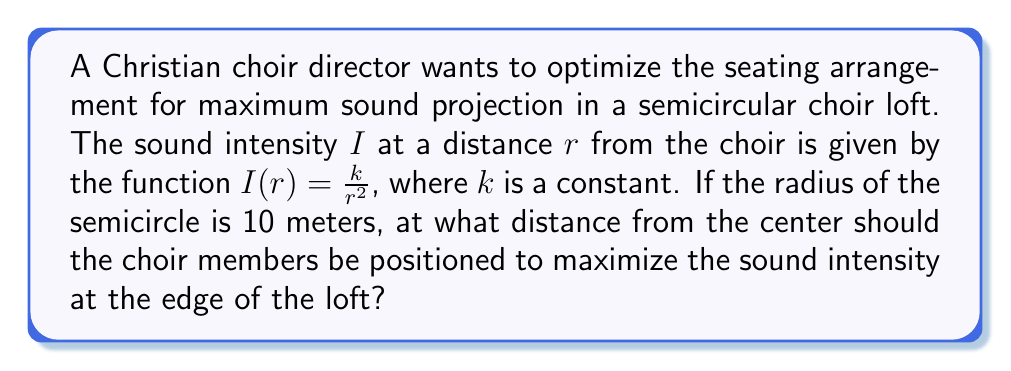Provide a solution to this math problem. 1) We need to find the maximum of the function $I(r)$ when $r$ is between 0 and 10 meters.

2) The derivative of $I(r)$ with respect to $r$ is:
   $$\frac{dI}{dr} = -\frac{2k}{r^3}$$

3) To find the maximum, we set the derivative to zero:
   $$-\frac{2k}{r^3} = 0$$

4) However, this equation is only satisfied when $r$ approaches infinity, which is not in our domain.

5) This means the maximum must occur at one of the endpoints of our domain: either at $r = 0$ or $r = 10$.

6) We can't evaluate $I(0)$ as it would lead to division by zero, so the maximum must occur at $r = 0^+$ (as close to 0 as possible).

7) Therefore, to maximize sound intensity at the edge of the loft, the choir should be positioned as close to the center of the semicircle as practically possible.

8) In reality, choir members can't stand at exactly $r = 0$, so they should form a tight semicircle as close to the center as feasible while still allowing space for each member.
Answer: As close to the center as practically possible. 